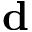<formula> <loc_0><loc_0><loc_500><loc_500>{ d }</formula> 